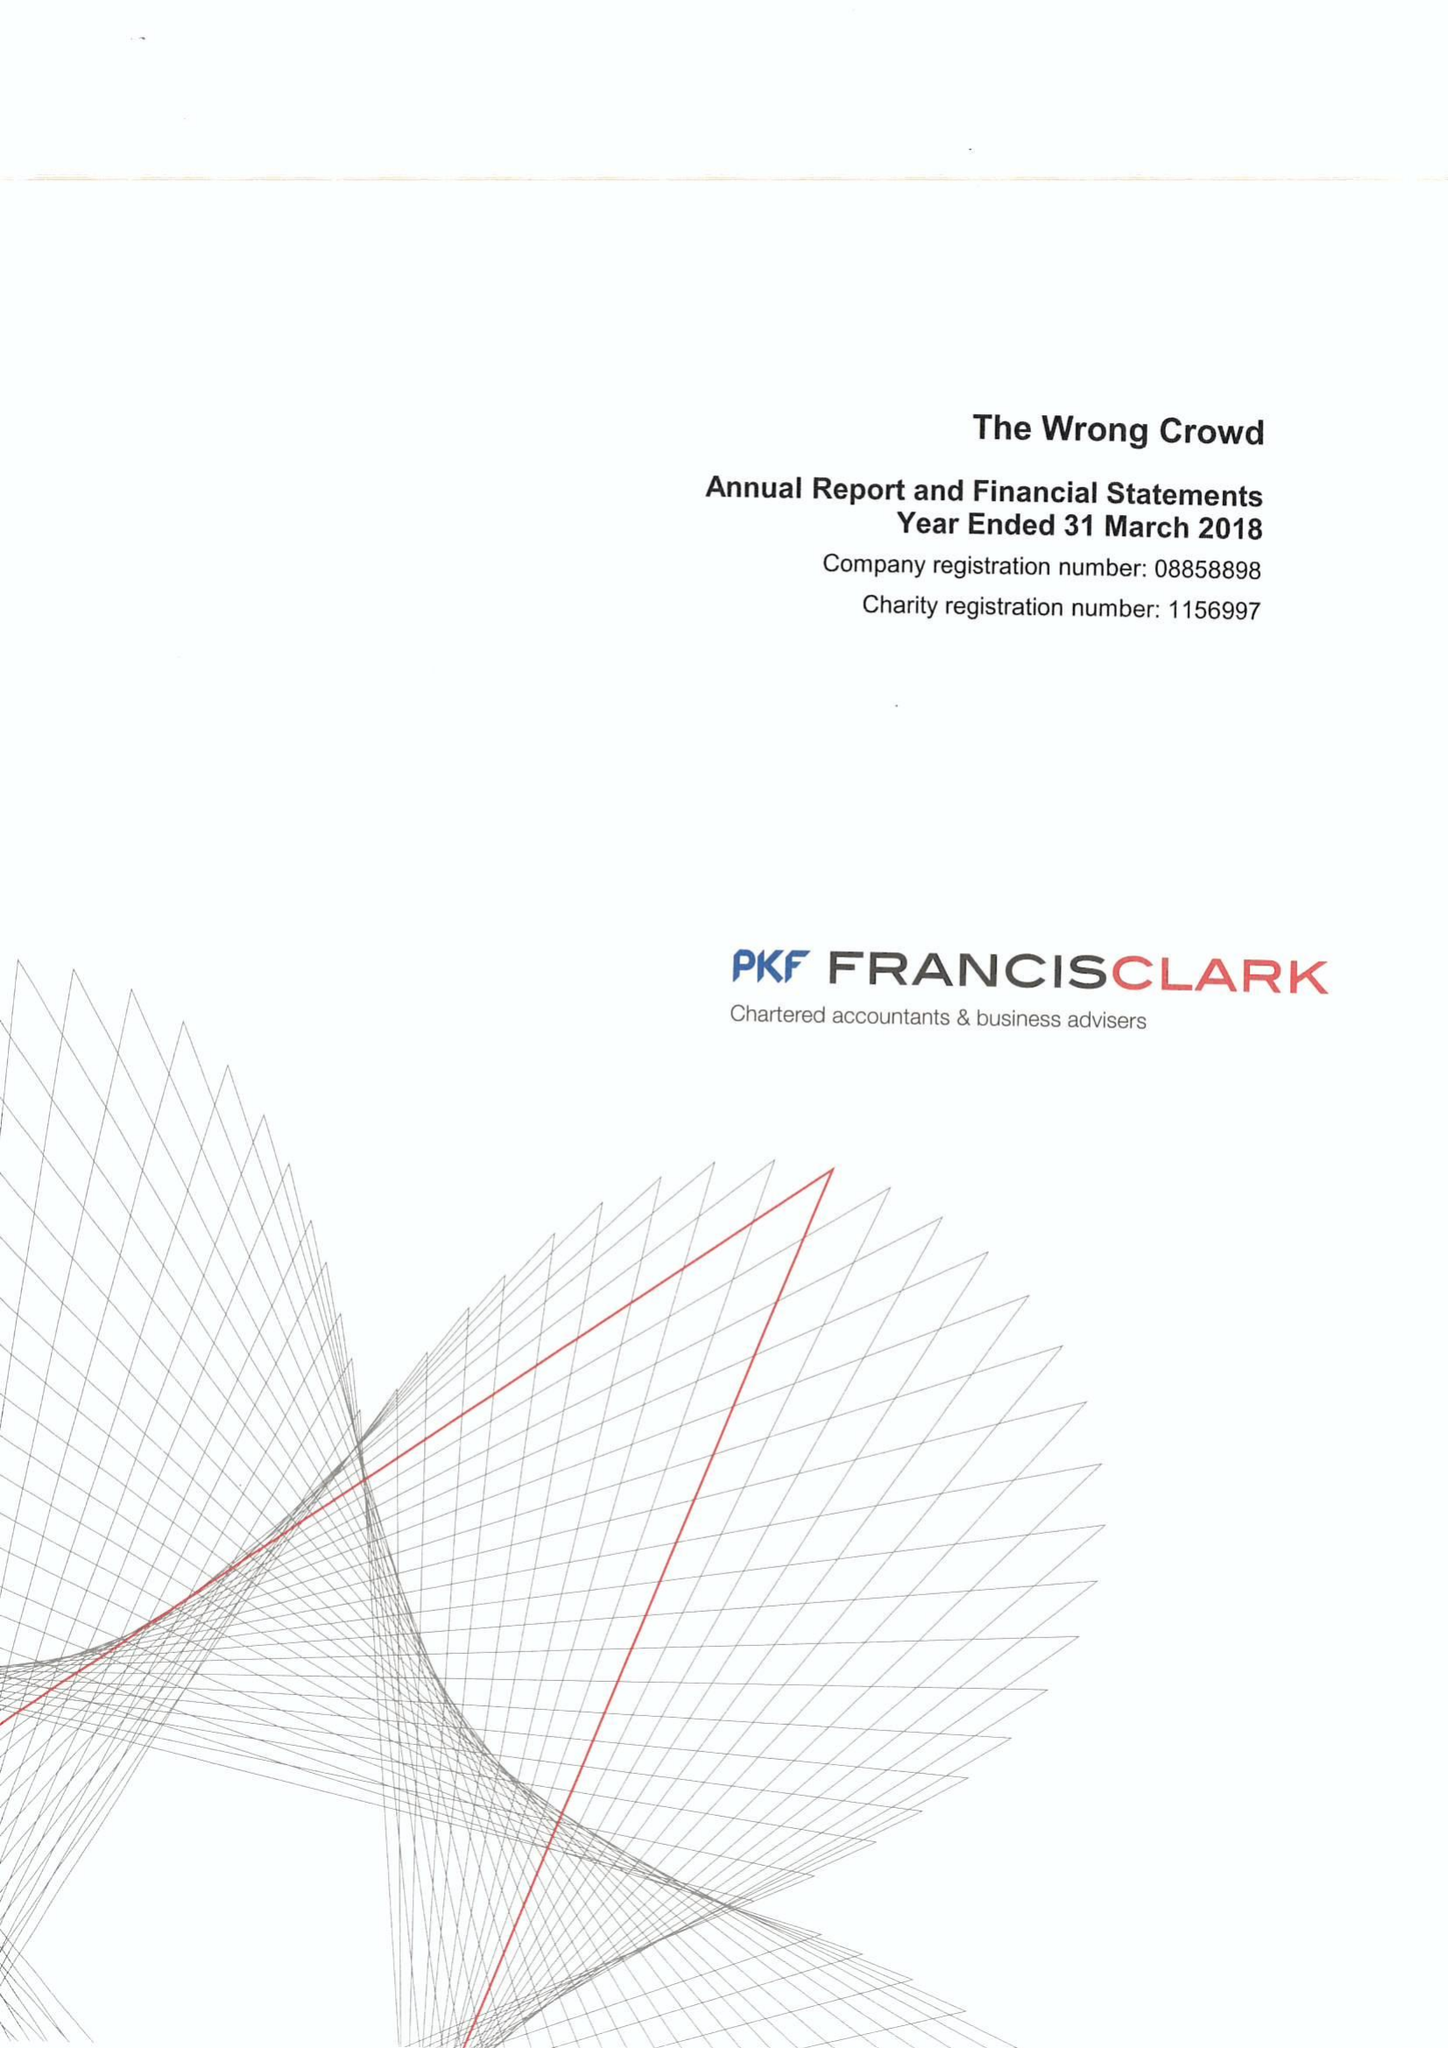What is the value for the charity_name?
Answer the question using a single word or phrase. The Wrong Crowd 